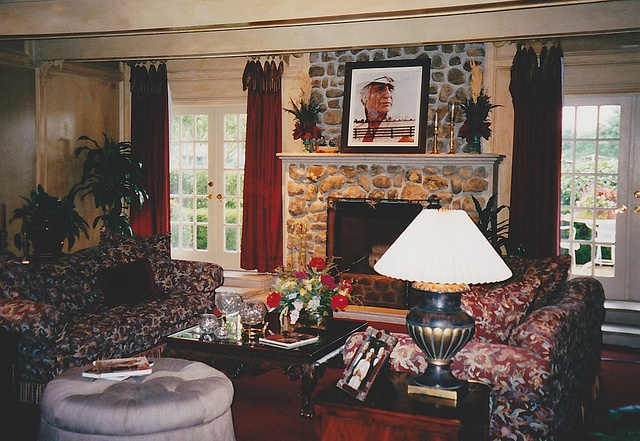Describe the objects in this image and their specific colors. I can see couch in black, gray, and maroon tones, couch in black, maroon, gray, and brown tones, potted plant in black, maroon, and gray tones, potted plant in black, brown, and maroon tones, and potted plant in black, maroon, and gray tones in this image. 